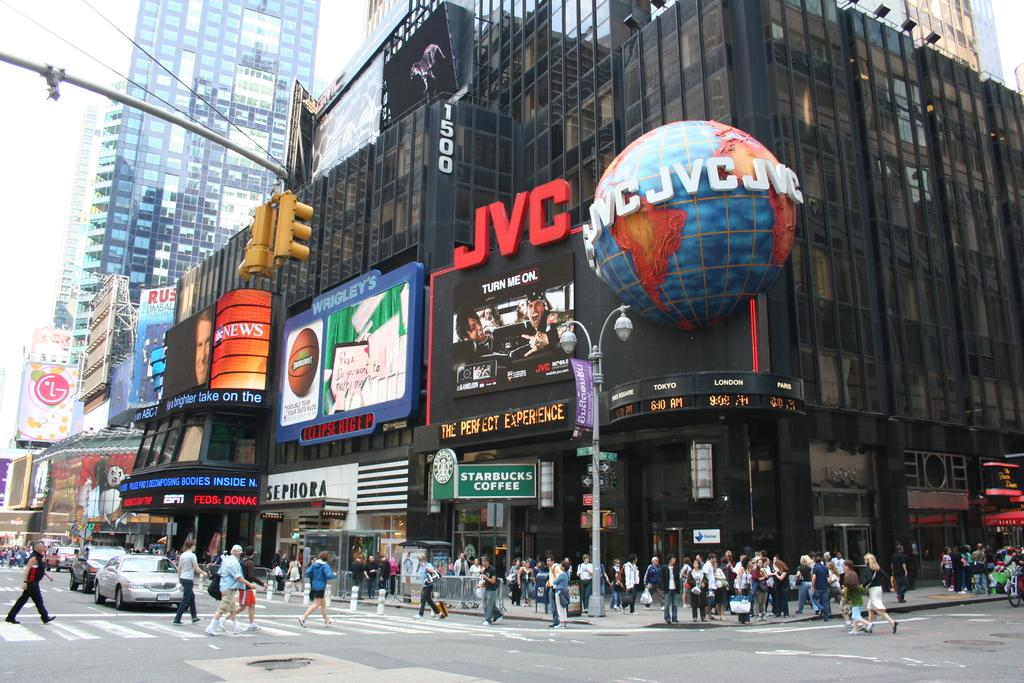What type of vehicles can be seen in the image? There are cars in the image. What are the people in the image doing? There is a group of people walking on the road in the image. What is the purpose of the pole in the image? The pole in the image could be a utility pole or a traffic signal pole. What type of structures are visible in the image? There are buildings in the image. What device is used to control traffic in the image? There is a traffic signal light in the image. What additional signage is present in the image? There are banners in the image. What color is the shirt worn by the corn in the middle of the image? There is no corn or shirt present in the image. 